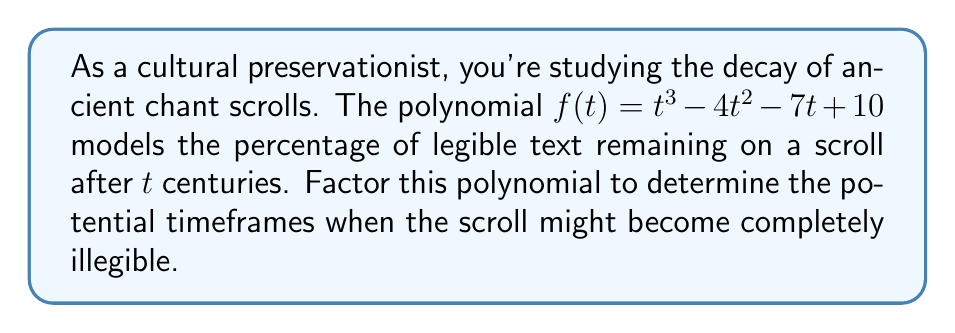Teach me how to tackle this problem. To factor this polynomial, we'll follow these steps:

1) First, let's check if there are any rational roots using the rational root theorem. The possible rational roots are the factors of the constant term: ±1, ±2, ±5, ±10.

2) Testing these values, we find that $f(2) = 0$. So $(t-2)$ is a factor.

3) We can use polynomial long division to divide $f(t)$ by $(t-2)$:

   $$t^3 - 4t^2 - 7t + 10 = (t-2)(t^2 - 2t - 5)$$

4) Now we need to factor the quadratic term $t^2 - 2t - 5$. We can do this by finding two numbers that multiply to give -5 and add to give -2.

5) These numbers are -5 and 3. So we can factor the quadratic as:

   $$(t-5)(t+3)$$

6) Putting it all together, we get:

   $$f(t) = (t-2)(t-5)(t+3)$$

This factorization gives us the roots of the polynomial, which are the potential times when the scroll might become completely illegible (i.e., when the percentage of legible text reaches 0).
Answer: $f(t) = (t-2)(t-5)(t+3)$ 